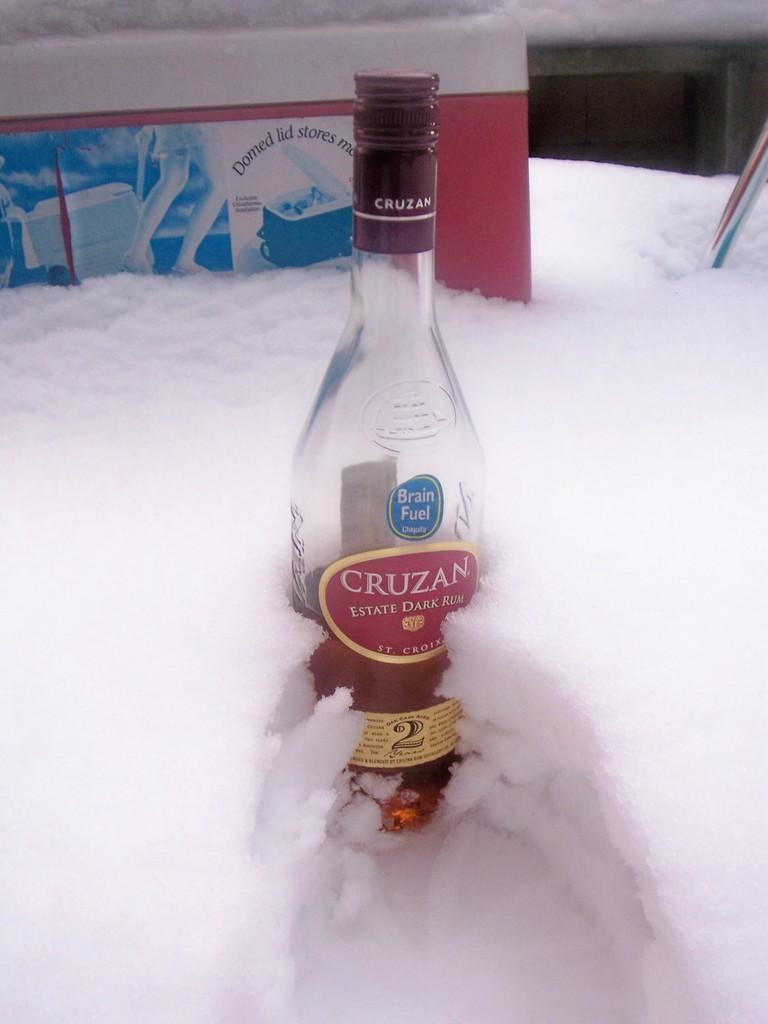What object can be seen in the image with a red label? There is a bottle in the image with a red color label. What is written on the label of the bottle? The label has "CRUZEN 2" written on it. What can be seen in the background of the image? There is a banner and a wall in the background of the image. What type of love can be seen in the image? There is no love present in the image; it features a bottle with a label and a background with a banner and a wall. What time of day does the image depict? The time of day is not mentioned or depicted in the image. 